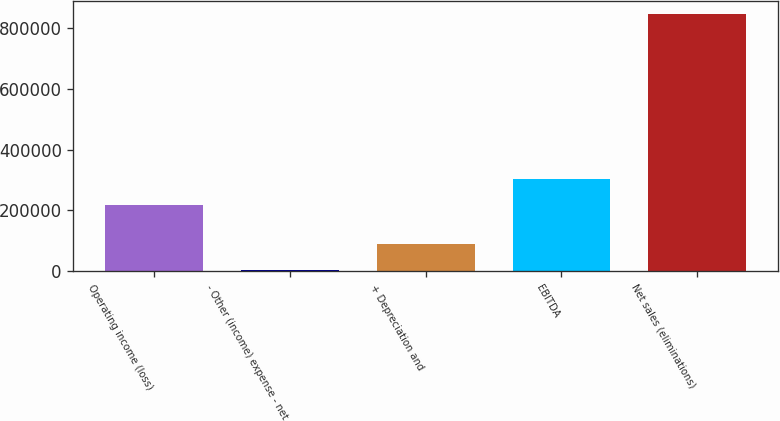Convert chart to OTSL. <chart><loc_0><loc_0><loc_500><loc_500><bar_chart><fcel>Operating income (loss)<fcel>- Other (income) expense - net<fcel>+ Depreciation and<fcel>EBITDA<fcel>Net sales (eliminations)<nl><fcel>217500<fcel>3066<fcel>87669.5<fcel>302104<fcel>849101<nl></chart> 